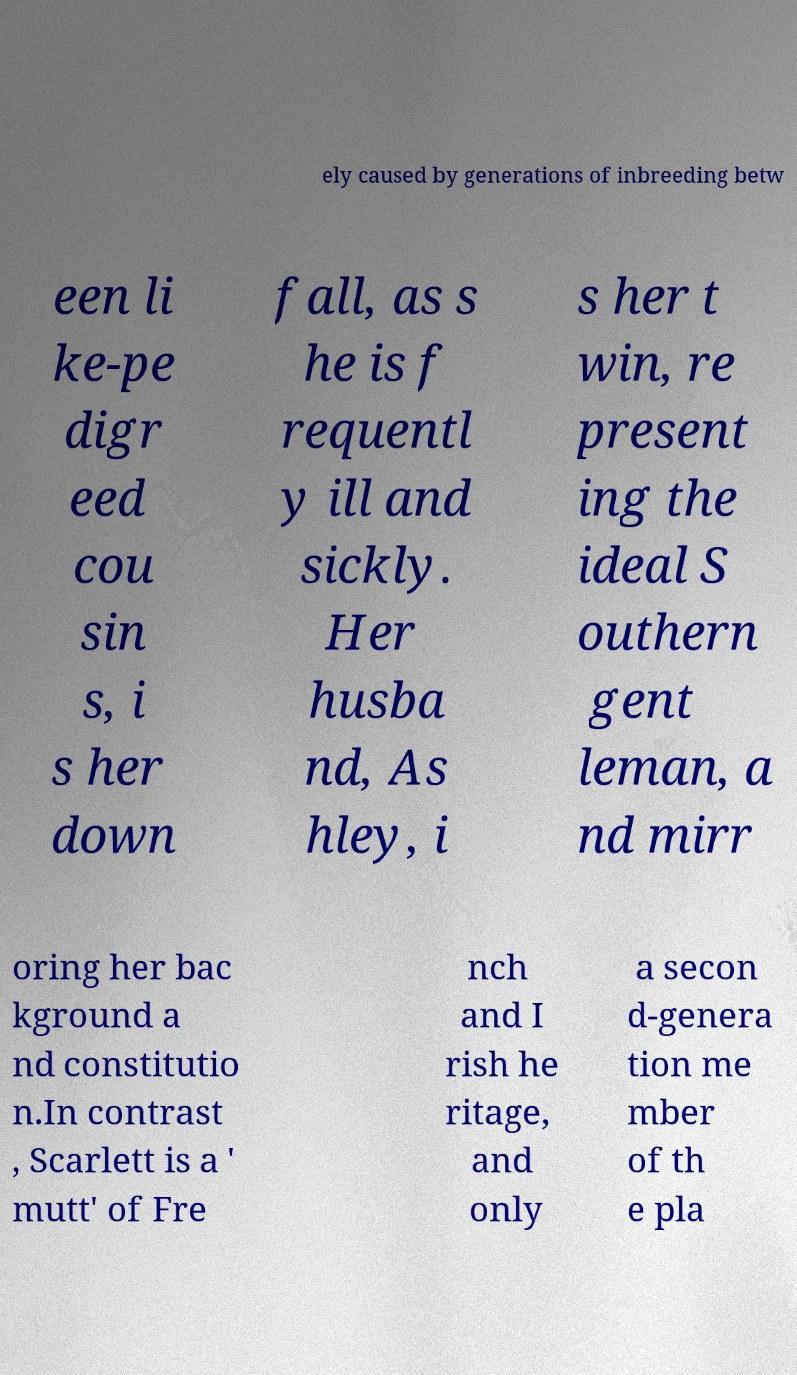Please read and relay the text visible in this image. What does it say? ely caused by generations of inbreeding betw een li ke-pe digr eed cou sin s, i s her down fall, as s he is f requentl y ill and sickly. Her husba nd, As hley, i s her t win, re present ing the ideal S outhern gent leman, a nd mirr oring her bac kground a nd constitutio n.In contrast , Scarlett is a ' mutt' of Fre nch and I rish he ritage, and only a secon d-genera tion me mber of th e pla 